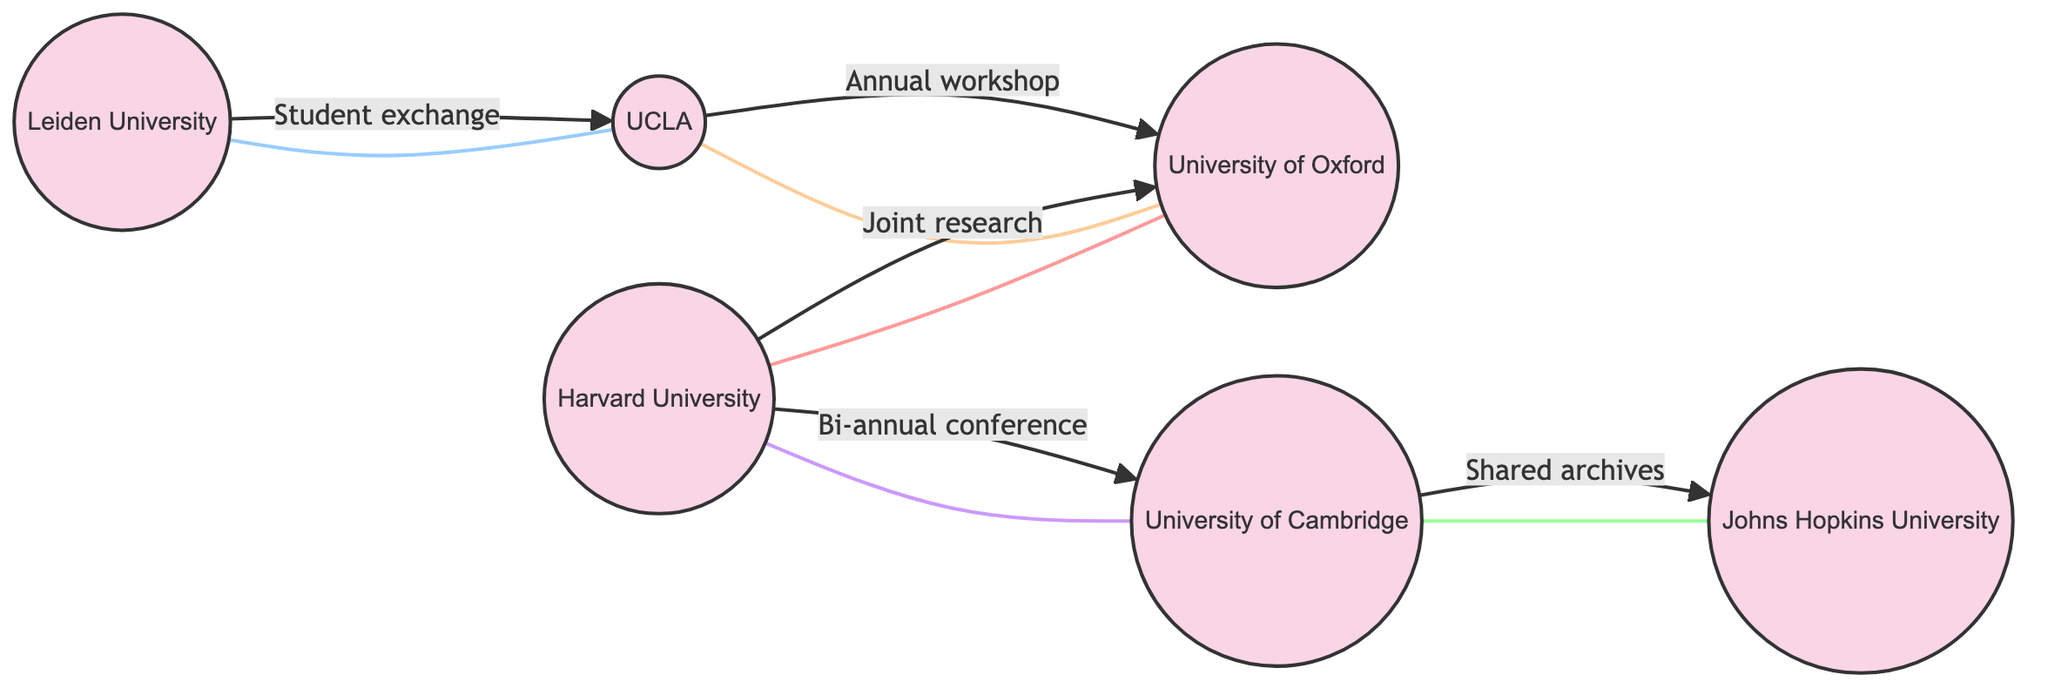What is the total number of institutions in the diagram? There are six nodes representing institutions in the diagram: Harvard University, University of Oxford, Leiden University, UCLA, University of Cambridge, and Johns Hopkins University.
Answer: 6 Which institution collaborates with Harvard University? Harvard University collaborates with University of Oxford and University of Cambridge, as indicated by the edges connecting them.
Answer: University of Oxford, University of Cambridge What type of exchange program does Leiden University have? Leiden University has a student exchange program with UCLA, focusing on feminist perspectives in Egyptology, as described in the edge connecting them.
Answer: Student exchange How many edges are there in the network? The diagram contains five edges representing collaborative relationships between the institutions.
Answer: 5 Which institution is connected to UCLA through a workshop? UCLA is connected to the University of Oxford through an annual workshop on Gender Studies in Ancient Egypt.
Answer: University of Oxford What is the nature of the connection between Cambridge and Johns Hopkins University? The connection between University of Cambridge and Johns Hopkins University is described as a collaboration involving shared digital archives on gender artifacts from Egypt.
Answer: Collaboration Which university offers a program for the study of Women, Gender, and Sexuality? Johns Hopkins University offers a program for the study of Women, Gender, and Sexuality, as indicated in its department description.
Answer: Johns Hopkins University How many institutions focus on Gender Studies in their departments? Four institutions focus on Gender Studies in their departments: Harvard University, UCLA, University of Cambridge, and Johns Hopkins University.
Answer: 4 Which edge describes the bi-annual conference? The edge connecting Harvard University and Cambridge describes the bi-annual conference on Feminism in Archaeology.
Answer: Bi-annual conference 